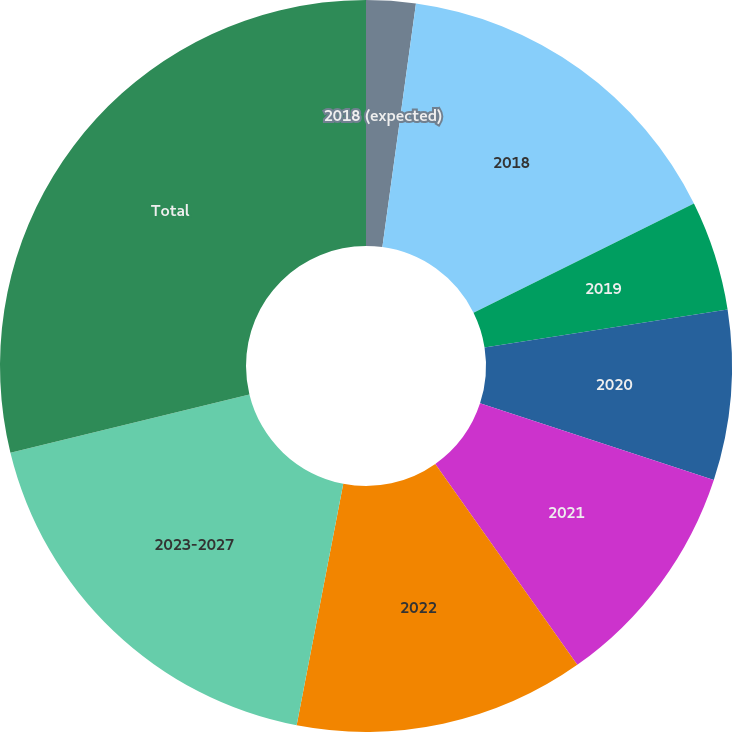<chart> <loc_0><loc_0><loc_500><loc_500><pie_chart><fcel>2018 (expected)<fcel>2018<fcel>2019<fcel>2020<fcel>2021<fcel>2022<fcel>2023-2027<fcel>Total<nl><fcel>2.18%<fcel>15.5%<fcel>4.85%<fcel>7.51%<fcel>10.17%<fcel>12.83%<fcel>18.16%<fcel>28.81%<nl></chart> 